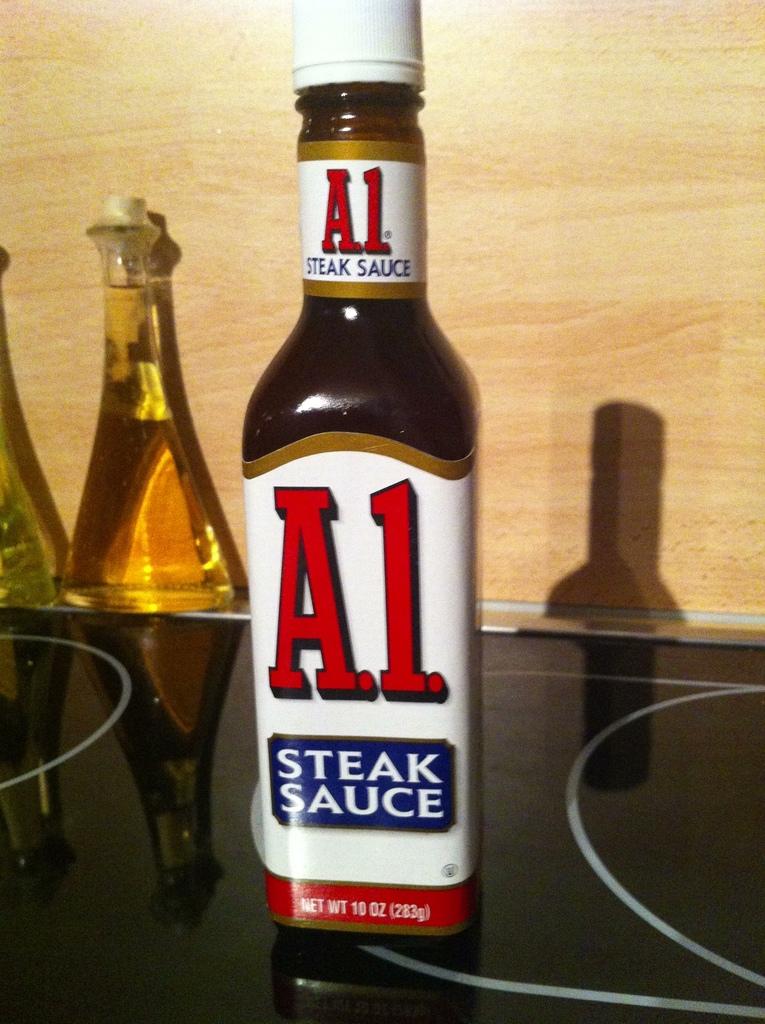What brand of steak sauce is this?
Your answer should be very brief. A1. How many ounces of sauce are in this bottle?
Your response must be concise. 10. 